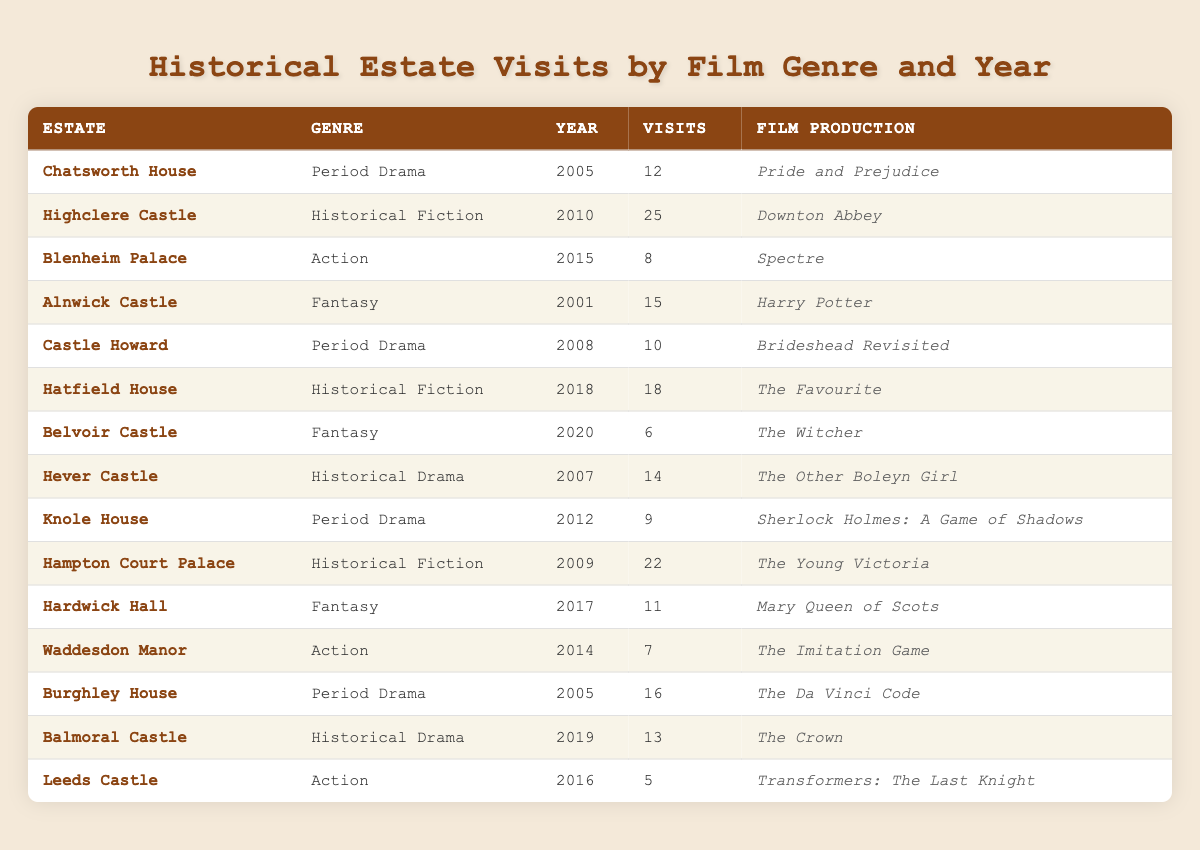What is the total number of visits recorded for the estate Chatsworth House? By looking at the row for Chatsworth House, we can see it has a recorded total of 12 visits.
Answer: 12 What is the genre of the film production for the estate Highclere Castle? The row for Highclere Castle indicates that the genre of the film production is Historical Fiction.
Answer: Historical Fiction How many films were produced in the year 2015? To find the number of films produced in 2015, we look at the table and see that there are two estates listed: Blenheim Palace and Waddesdon Manor, thus there were two productions that year.
Answer: 2 Which genre had the most visits in total? We need to sum up the visits for each genre: Period Drama (38), Historical Fiction (47), Action (20), Fantasy (32), and Historical Drama (27). The highest number is for Historical Fiction with 47 visits.
Answer: Historical Fiction Did any films featured at Blenheim Palace also receive a higher number of visits than the films at Leeds Castle? Blenheim Palace had 8 visits for Spectre, while Leeds Castle had 5 visits for Transformers: The Last Knight. Thus, yes, Spectre received a higher number of visits than the film at Leeds Castle.
Answer: Yes What is the average number of visits across all estates for the genre Fantasy? The estates with the Fantasy genre are Alnwick Castle (15 visits), Belvoir Castle (6 visits), and Hardwick Hall (11 visits). The total visits are 15 + 6 + 11 = 32. Dividing this by 3 gives an average of 32/3 ≈ 10.67 visits.
Answer: 10.67 In which year did the estate with the least visits occur? After examining the data, Leeds Castle has the least visits recorded, with only 5 visits in 2016.
Answer: 2016 How many total visits were made for Historical Drama films? The two estates under Historical Drama are Hever Castle (14 visits) and Balmoral Castle (13 visits). Summing these gives 14 + 13 = 27 visits in total.
Answer: 27 Is there an estate that had a film production in more than one genre? Looking through the table, none of the estates appear in more than one genre, each is distinctly categorized.
Answer: No 